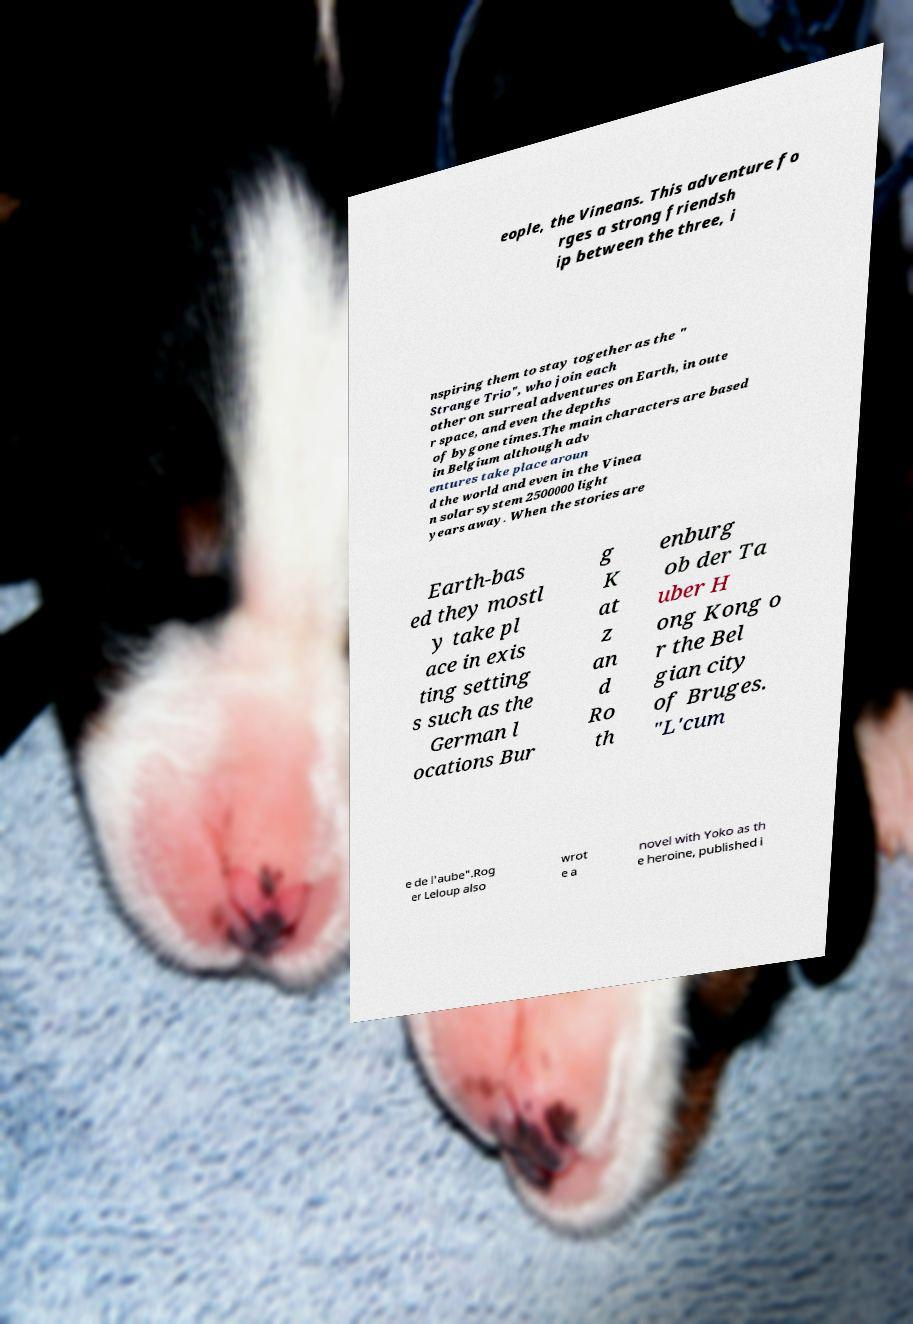Please identify and transcribe the text found in this image. eople, the Vineans. This adventure fo rges a strong friendsh ip between the three, i nspiring them to stay together as the " Strange Trio", who join each other on surreal adventures on Earth, in oute r space, and even the depths of bygone times.The main characters are based in Belgium although adv entures take place aroun d the world and even in the Vinea n solar system 2500000 light years away. When the stories are Earth-bas ed they mostl y take pl ace in exis ting setting s such as the German l ocations Bur g K at z an d Ro th enburg ob der Ta uber H ong Kong o r the Bel gian city of Bruges. "L'cum e de l'aube".Rog er Leloup also wrot e a novel with Yoko as th e heroine, published i 